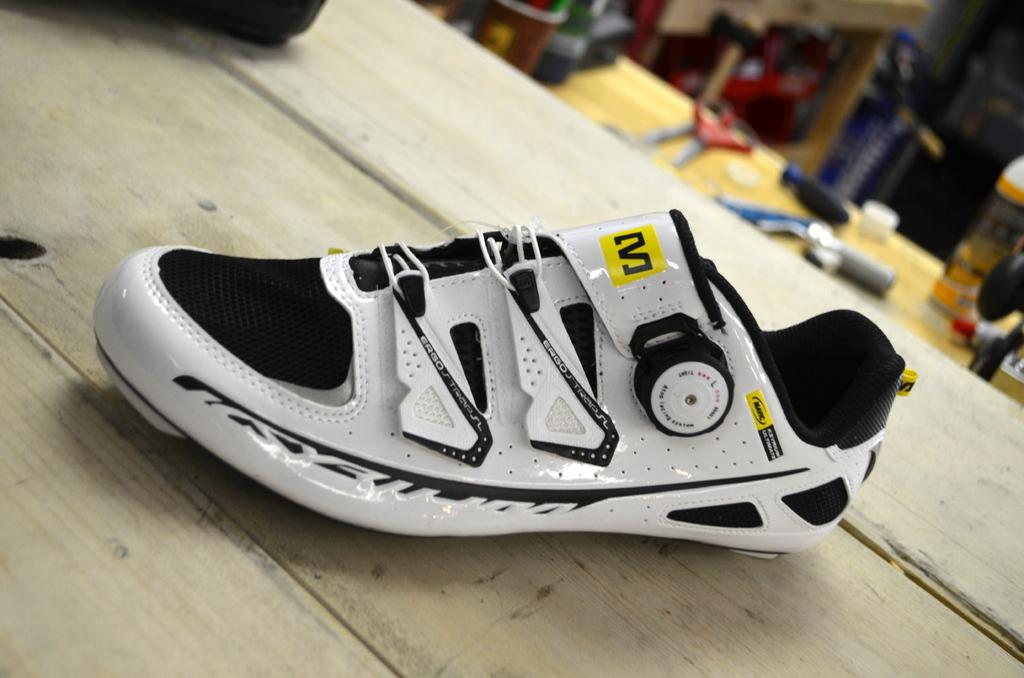What is the main subject of the image? There is a show on a table in the image. Can you describe the table in the image? The table has objects placed on it in the background. What type of machine is being used to make observations in the image? There is no machine or observation process depicted in the image; it only shows a show on a table and objects placed on the table in the background. 